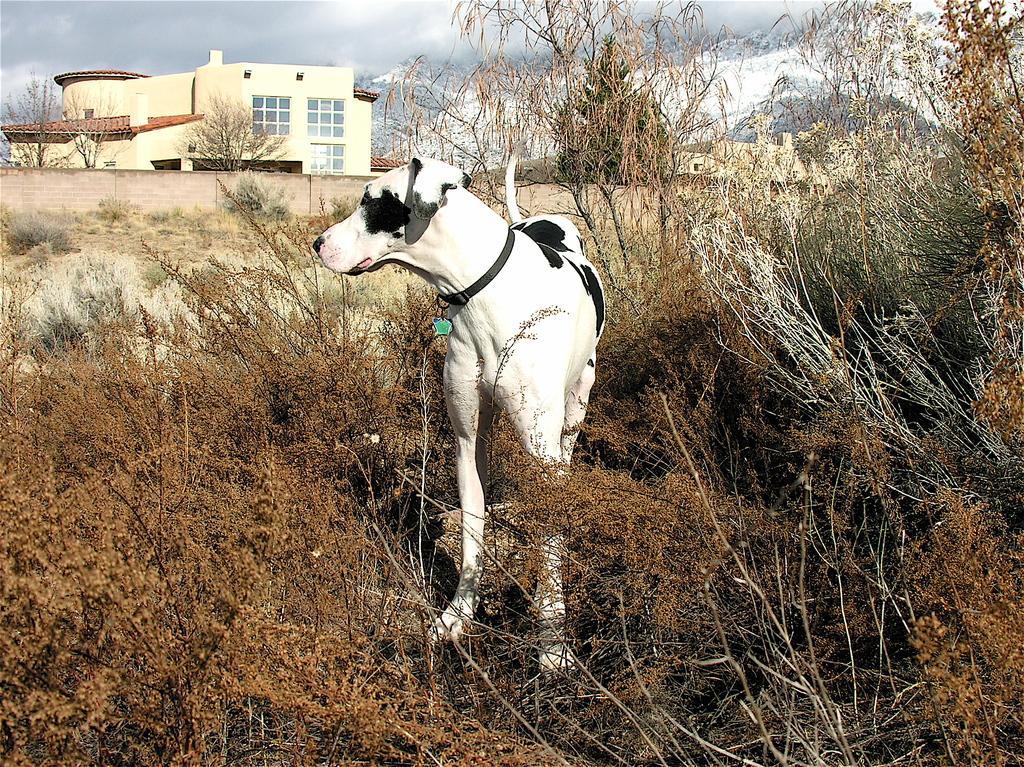In one or two sentences, can you explain what this image depicts? Here we can see a dog standing on the ground,we can also see bare plants and trees. In the background there are bare trees,buildings,mountain,wall and clouds in the sky. 